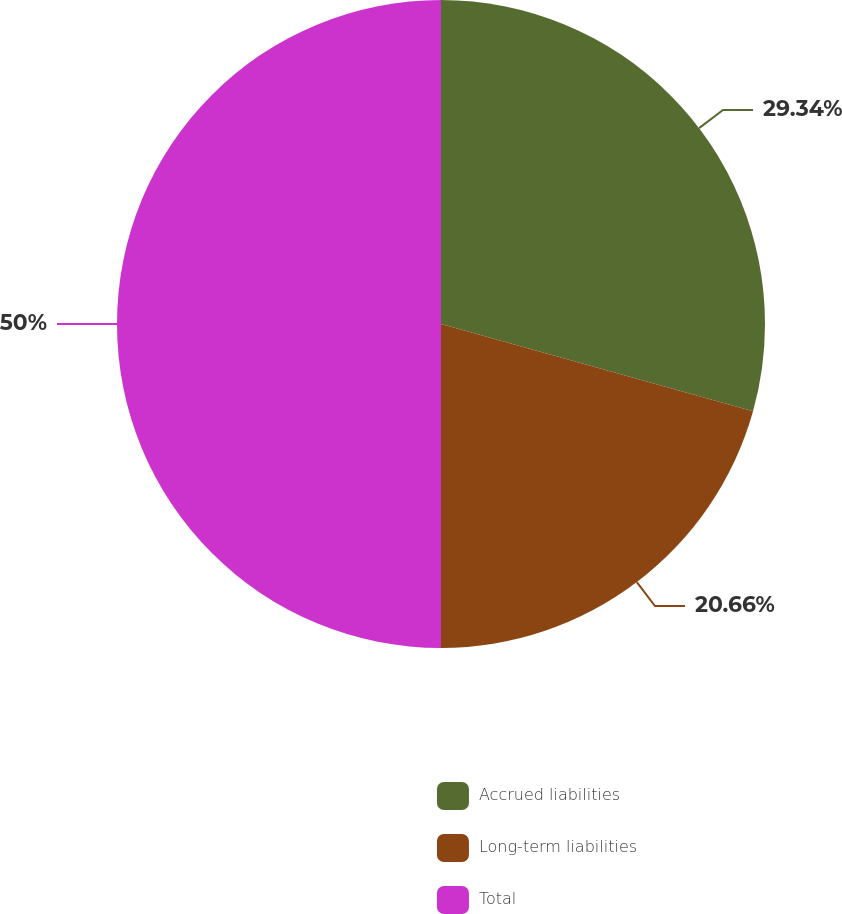Convert chart to OTSL. <chart><loc_0><loc_0><loc_500><loc_500><pie_chart><fcel>Accrued liabilities<fcel>Long-term liabilities<fcel>Total<nl><fcel>29.34%<fcel>20.66%<fcel>50.0%<nl></chart> 